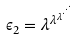Convert formula to latex. <formula><loc_0><loc_0><loc_500><loc_500>\epsilon _ { 2 } = \lambda ^ { \lambda ^ { \lambda ^ { \cdot ^ { \cdot ^ { \cdot } } } } }</formula> 